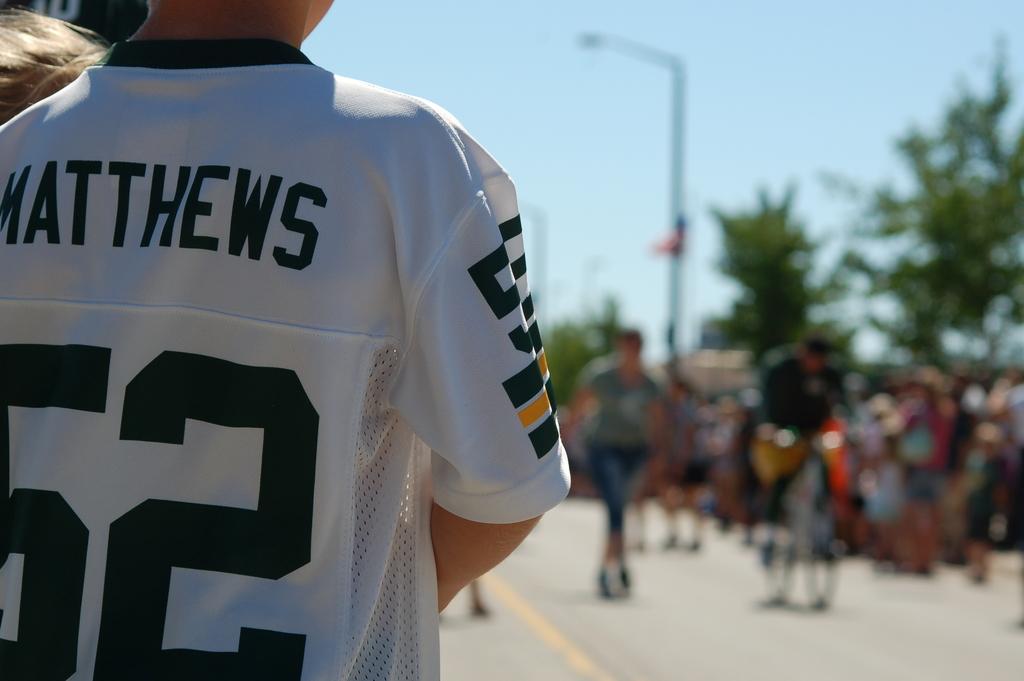What is the name of number 52?
Provide a succinct answer. Matthews. What number is on the back of the white jersey?
Your answer should be compact. 52. 